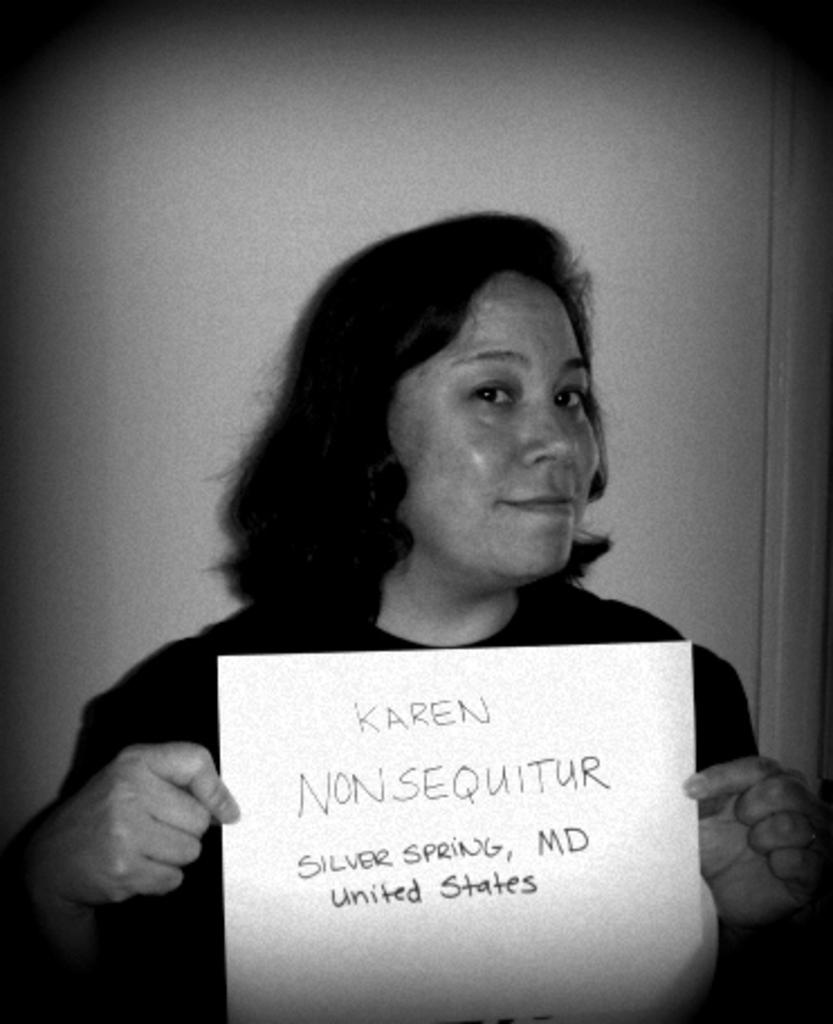Who is present in the image? There is a woman in the image. What is the woman holding? The woman is holding a paper. What can be seen in the background of the image? There is a wall in the background of the image. What type of ornament is hanging from the woman's neck in the image? There is no ornament visible around the woman's neck in the image. Can you solve the riddle written on the paper the woman is holding? We cannot solve the riddle, as the text on the paper is not visible in the image. 